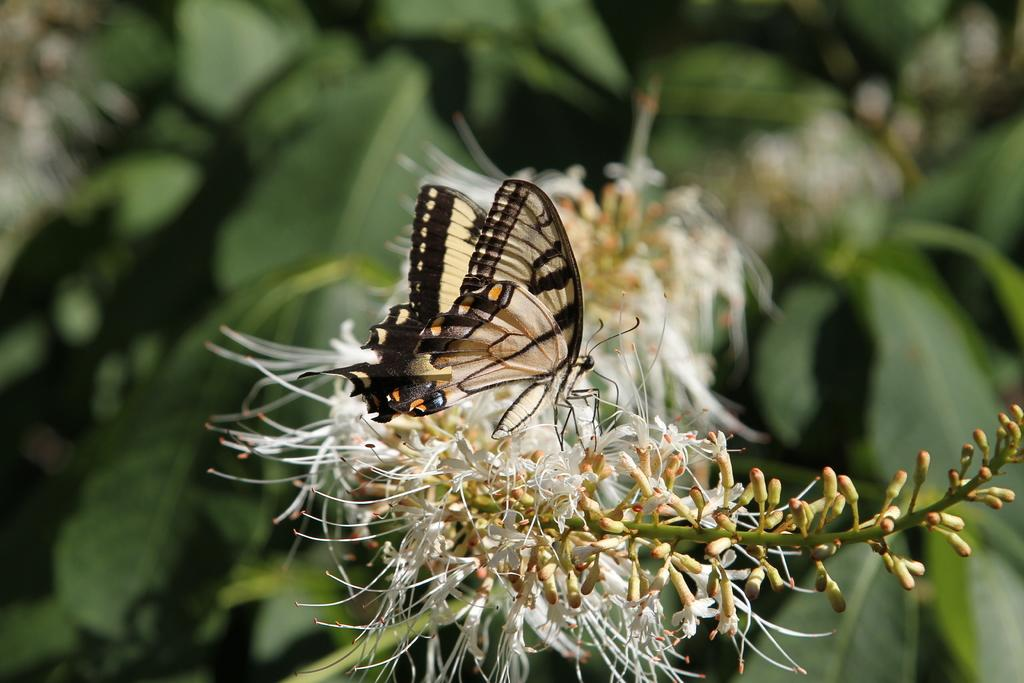What is the main subject of the image? There is a butterfly in the image. Where is the butterfly located? The butterfly is on a flower. What can be seen in the background of the image? There are leaves in the background of the image. What type of hat is the butterfly wearing in the image? There is no hat present on the butterfly in the image. 